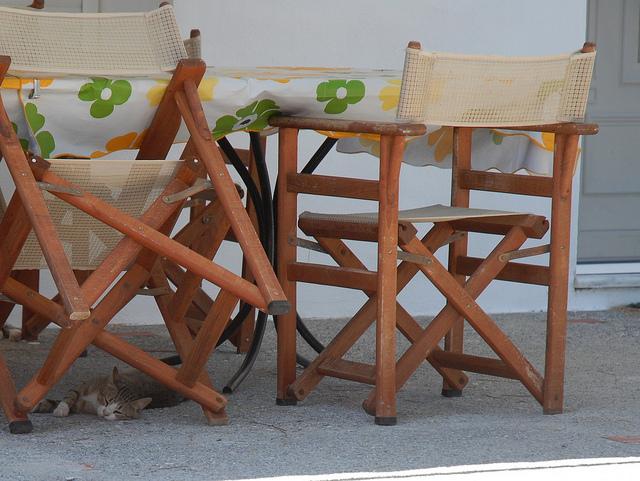What is the cat laying on?
Keep it brief. Floor. What is the chair made of?
Quick response, please. Wood. Are there flowers in the picture?
Answer briefly. Yes. What kind of cat is shown?
Quick response, please. Tabby. 